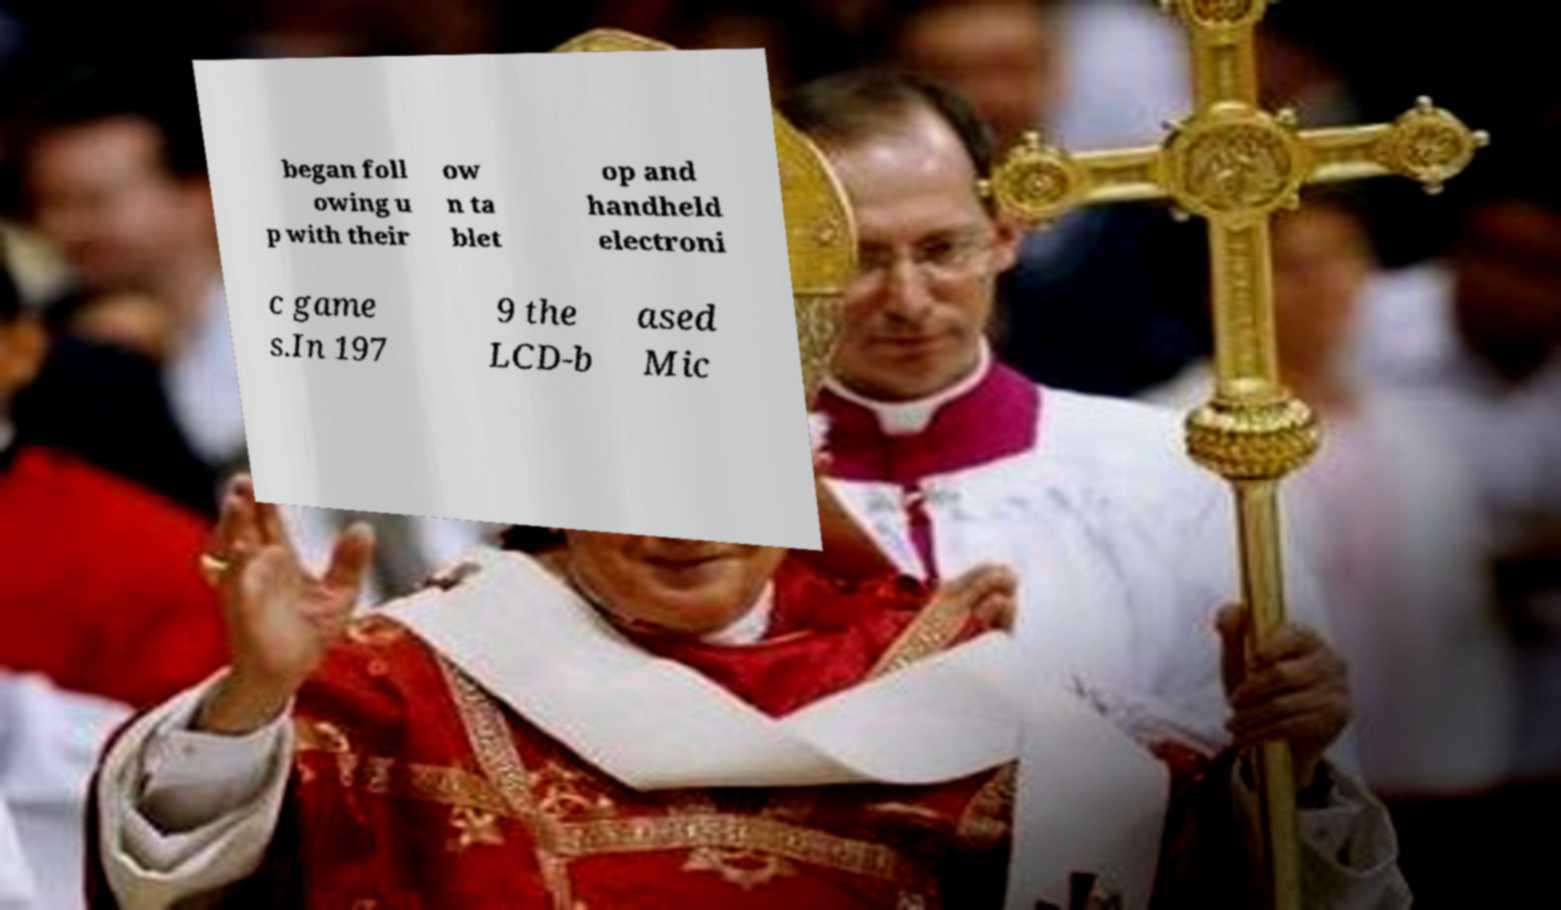For documentation purposes, I need the text within this image transcribed. Could you provide that? began foll owing u p with their ow n ta blet op and handheld electroni c game s.In 197 9 the LCD-b ased Mic 